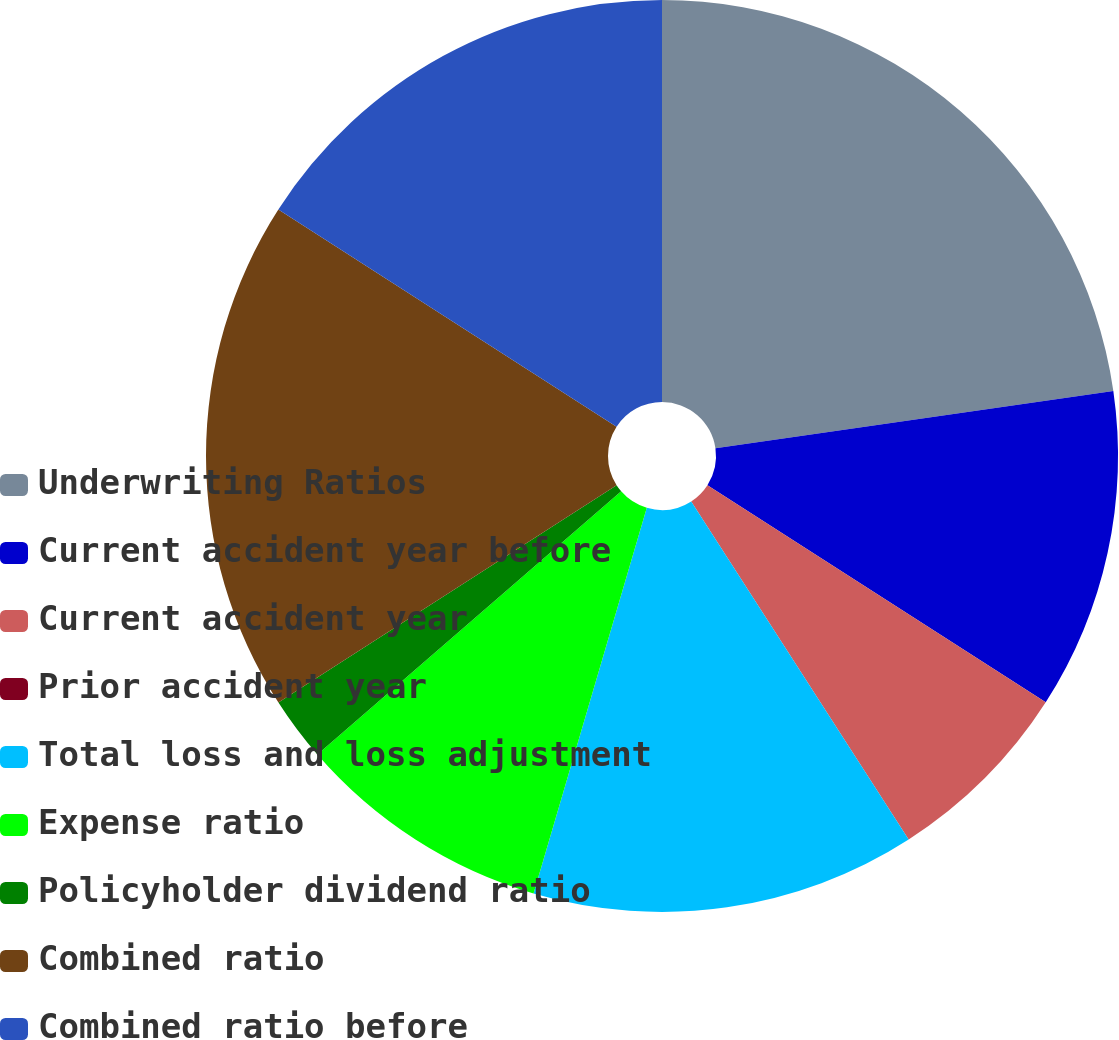Convert chart. <chart><loc_0><loc_0><loc_500><loc_500><pie_chart><fcel>Underwriting Ratios<fcel>Current accident year before<fcel>Current accident year<fcel>Prior accident year<fcel>Total loss and loss adjustment<fcel>Expense ratio<fcel>Policyholder dividend ratio<fcel>Combined ratio<fcel>Combined ratio before<nl><fcel>22.72%<fcel>11.36%<fcel>6.82%<fcel>0.0%<fcel>13.64%<fcel>9.09%<fcel>2.27%<fcel>18.18%<fcel>15.91%<nl></chart> 